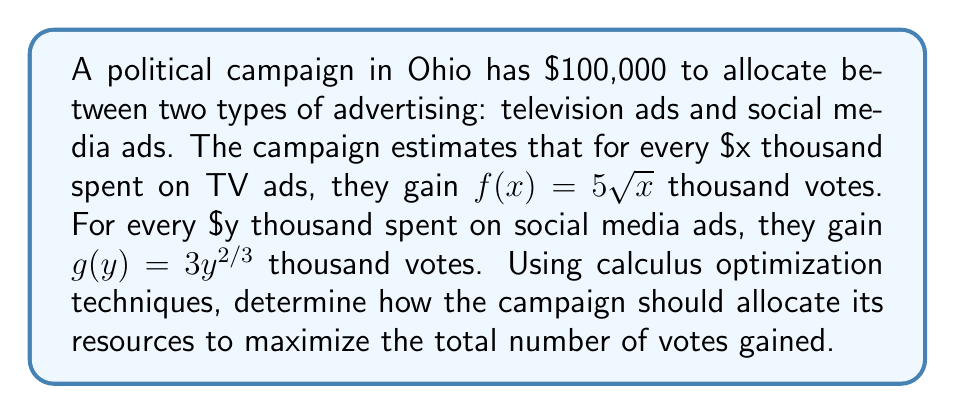Provide a solution to this math problem. To solve this optimization problem, we'll follow these steps:

1) Let $x$ be the amount (in thousands) spent on TV ads and $y$ be the amount spent on social media ads.

2) The constraint equation is:
   $x + y = 100$ (since the total budget is $100,000)

3) The objective function to maximize is:
   $V(x,y) = f(x) + g(y) = 5\sqrt{x} + 3y^{2/3}$

4) We can eliminate one variable using the constraint. Let's express $y$ in terms of $x$:
   $y = 100 - x$

5) Now our objective function becomes a function of one variable:
   $V(x) = 5\sqrt{x} + 3(100-x)^{2/3}$

6) To find the maximum, we differentiate $V(x)$ and set it to zero:

   $$\frac{dV}{dx} = \frac{5}{2\sqrt{x}} - 2(100-x)^{-1/3} = 0$$

7) Solving this equation analytically is difficult, so we'll use numerical methods. Using a graphing calculator or computer software, we find that this equation is satisfied when $x \approx 69.44$.

8) We can verify this is a maximum by checking the second derivative is negative at this point.

9) Therefore, $y = 100 - 69.44 = 30.56$

10) Converting back to dollars:
    TV ads: $69,440
    Social media ads: $30,560

11) We can calculate the votes gained:
    TV ads: $5\sqrt{69.44} \approx 41.6$ thousand votes
    Social media ads: $3(30.56)^{2/3} \approx 27.8$ thousand votes
    Total: $69.4$ thousand votes
Answer: The optimal allocation is approximately $69,440 for TV ads and $30,560 for social media ads, resulting in a gain of about 69,400 votes. 